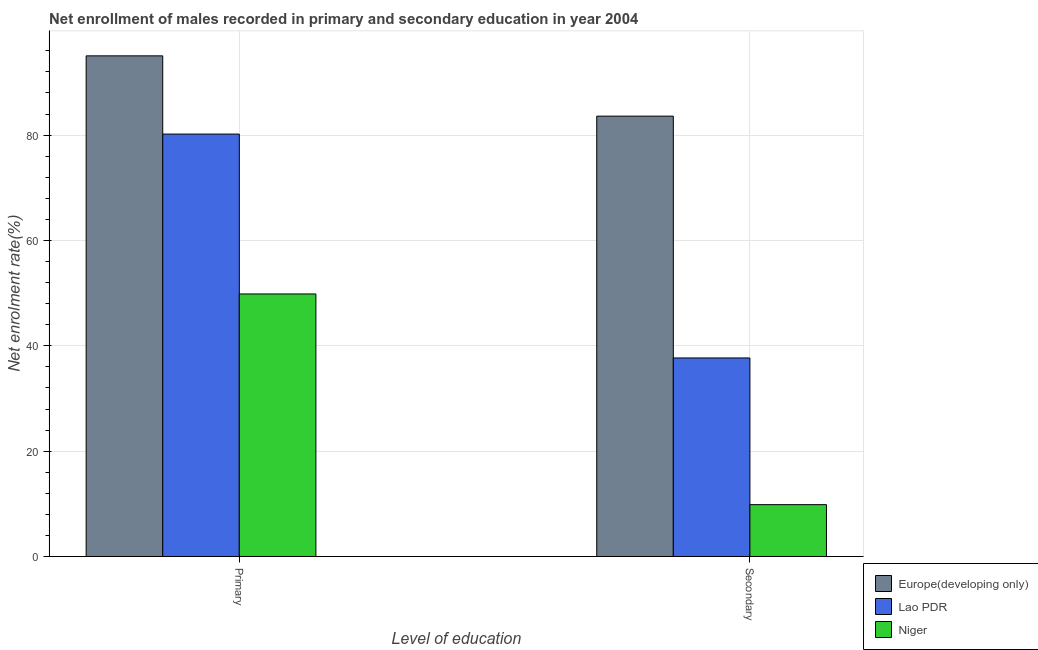Are the number of bars per tick equal to the number of legend labels?
Keep it short and to the point. Yes. What is the label of the 1st group of bars from the left?
Provide a succinct answer. Primary. What is the enrollment rate in primary education in Europe(developing only)?
Ensure brevity in your answer.  95.04. Across all countries, what is the maximum enrollment rate in secondary education?
Your answer should be compact. 83.59. Across all countries, what is the minimum enrollment rate in secondary education?
Provide a short and direct response. 9.85. In which country was the enrollment rate in secondary education maximum?
Your response must be concise. Europe(developing only). In which country was the enrollment rate in primary education minimum?
Give a very brief answer. Niger. What is the total enrollment rate in secondary education in the graph?
Provide a short and direct response. 131.13. What is the difference between the enrollment rate in primary education in Niger and that in Lao PDR?
Ensure brevity in your answer.  -30.35. What is the difference between the enrollment rate in secondary education in Lao PDR and the enrollment rate in primary education in Niger?
Your answer should be very brief. -12.15. What is the average enrollment rate in secondary education per country?
Keep it short and to the point. 43.71. What is the difference between the enrollment rate in secondary education and enrollment rate in primary education in Europe(developing only)?
Keep it short and to the point. -11.44. In how many countries, is the enrollment rate in secondary education greater than 28 %?
Your answer should be compact. 2. What is the ratio of the enrollment rate in primary education in Niger to that in Lao PDR?
Offer a very short reply. 0.62. Is the enrollment rate in secondary education in Lao PDR less than that in Niger?
Keep it short and to the point. No. In how many countries, is the enrollment rate in primary education greater than the average enrollment rate in primary education taken over all countries?
Give a very brief answer. 2. What does the 3rd bar from the left in Primary represents?
Your answer should be compact. Niger. What does the 1st bar from the right in Secondary represents?
Your answer should be very brief. Niger. How many bars are there?
Offer a terse response. 6. Are all the bars in the graph horizontal?
Your answer should be compact. No. What is the difference between two consecutive major ticks on the Y-axis?
Give a very brief answer. 20. Are the values on the major ticks of Y-axis written in scientific E-notation?
Ensure brevity in your answer.  No. Does the graph contain any zero values?
Offer a terse response. No. Does the graph contain grids?
Make the answer very short. Yes. What is the title of the graph?
Provide a succinct answer. Net enrollment of males recorded in primary and secondary education in year 2004. What is the label or title of the X-axis?
Your response must be concise. Level of education. What is the label or title of the Y-axis?
Offer a terse response. Net enrolment rate(%). What is the Net enrolment rate(%) of Europe(developing only) in Primary?
Keep it short and to the point. 95.04. What is the Net enrolment rate(%) in Lao PDR in Primary?
Your answer should be very brief. 80.19. What is the Net enrolment rate(%) of Niger in Primary?
Keep it short and to the point. 49.84. What is the Net enrolment rate(%) in Europe(developing only) in Secondary?
Offer a very short reply. 83.59. What is the Net enrolment rate(%) in Lao PDR in Secondary?
Offer a very short reply. 37.69. What is the Net enrolment rate(%) in Niger in Secondary?
Your response must be concise. 9.85. Across all Level of education, what is the maximum Net enrolment rate(%) of Europe(developing only)?
Provide a short and direct response. 95.04. Across all Level of education, what is the maximum Net enrolment rate(%) in Lao PDR?
Provide a succinct answer. 80.19. Across all Level of education, what is the maximum Net enrolment rate(%) in Niger?
Offer a very short reply. 49.84. Across all Level of education, what is the minimum Net enrolment rate(%) in Europe(developing only)?
Make the answer very short. 83.59. Across all Level of education, what is the minimum Net enrolment rate(%) in Lao PDR?
Provide a short and direct response. 37.69. Across all Level of education, what is the minimum Net enrolment rate(%) of Niger?
Make the answer very short. 9.85. What is the total Net enrolment rate(%) in Europe(developing only) in the graph?
Keep it short and to the point. 178.63. What is the total Net enrolment rate(%) of Lao PDR in the graph?
Make the answer very short. 117.88. What is the total Net enrolment rate(%) of Niger in the graph?
Give a very brief answer. 59.69. What is the difference between the Net enrolment rate(%) in Europe(developing only) in Primary and that in Secondary?
Give a very brief answer. 11.44. What is the difference between the Net enrolment rate(%) of Lao PDR in Primary and that in Secondary?
Provide a succinct answer. 42.5. What is the difference between the Net enrolment rate(%) in Niger in Primary and that in Secondary?
Offer a very short reply. 39.99. What is the difference between the Net enrolment rate(%) of Europe(developing only) in Primary and the Net enrolment rate(%) of Lao PDR in Secondary?
Keep it short and to the point. 57.35. What is the difference between the Net enrolment rate(%) of Europe(developing only) in Primary and the Net enrolment rate(%) of Niger in Secondary?
Offer a terse response. 85.19. What is the difference between the Net enrolment rate(%) of Lao PDR in Primary and the Net enrolment rate(%) of Niger in Secondary?
Offer a very short reply. 70.34. What is the average Net enrolment rate(%) in Europe(developing only) per Level of education?
Your answer should be compact. 89.31. What is the average Net enrolment rate(%) of Lao PDR per Level of education?
Ensure brevity in your answer.  58.94. What is the average Net enrolment rate(%) in Niger per Level of education?
Ensure brevity in your answer.  29.84. What is the difference between the Net enrolment rate(%) in Europe(developing only) and Net enrolment rate(%) in Lao PDR in Primary?
Your answer should be compact. 14.85. What is the difference between the Net enrolment rate(%) of Europe(developing only) and Net enrolment rate(%) of Niger in Primary?
Your answer should be very brief. 45.2. What is the difference between the Net enrolment rate(%) in Lao PDR and Net enrolment rate(%) in Niger in Primary?
Keep it short and to the point. 30.35. What is the difference between the Net enrolment rate(%) in Europe(developing only) and Net enrolment rate(%) in Lao PDR in Secondary?
Provide a short and direct response. 45.9. What is the difference between the Net enrolment rate(%) in Europe(developing only) and Net enrolment rate(%) in Niger in Secondary?
Keep it short and to the point. 73.75. What is the difference between the Net enrolment rate(%) in Lao PDR and Net enrolment rate(%) in Niger in Secondary?
Make the answer very short. 27.84. What is the ratio of the Net enrolment rate(%) of Europe(developing only) in Primary to that in Secondary?
Provide a short and direct response. 1.14. What is the ratio of the Net enrolment rate(%) of Lao PDR in Primary to that in Secondary?
Offer a very short reply. 2.13. What is the ratio of the Net enrolment rate(%) of Niger in Primary to that in Secondary?
Your response must be concise. 5.06. What is the difference between the highest and the second highest Net enrolment rate(%) in Europe(developing only)?
Provide a short and direct response. 11.44. What is the difference between the highest and the second highest Net enrolment rate(%) in Lao PDR?
Offer a terse response. 42.5. What is the difference between the highest and the second highest Net enrolment rate(%) in Niger?
Offer a terse response. 39.99. What is the difference between the highest and the lowest Net enrolment rate(%) of Europe(developing only)?
Your answer should be very brief. 11.44. What is the difference between the highest and the lowest Net enrolment rate(%) of Lao PDR?
Keep it short and to the point. 42.5. What is the difference between the highest and the lowest Net enrolment rate(%) in Niger?
Your answer should be very brief. 39.99. 